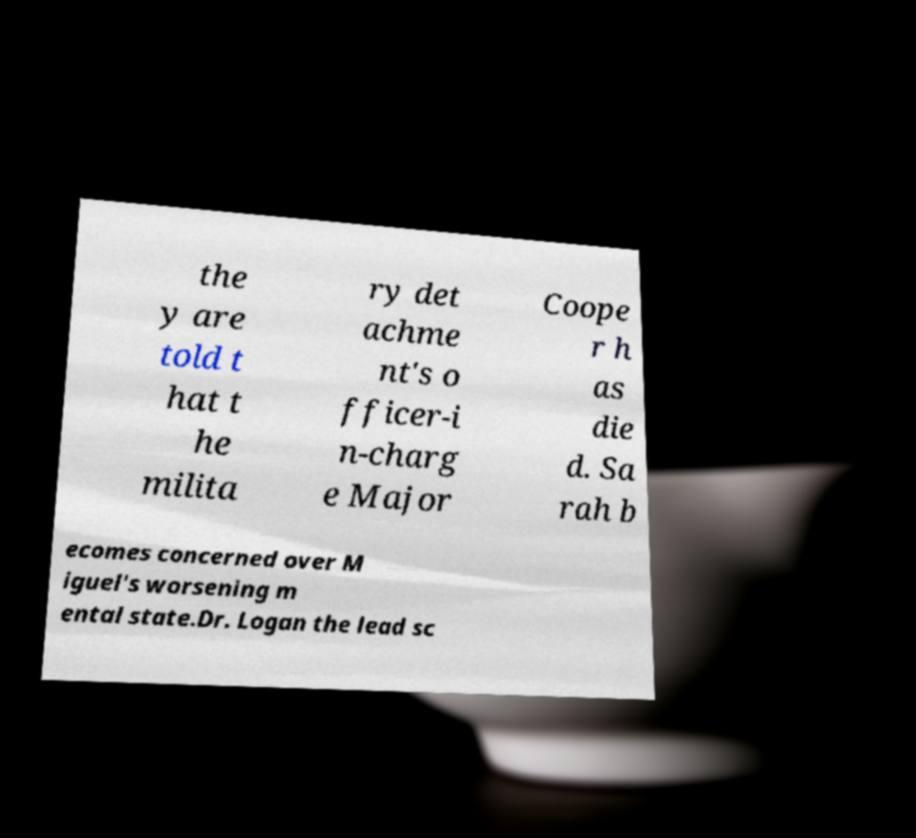For documentation purposes, I need the text within this image transcribed. Could you provide that? the y are told t hat t he milita ry det achme nt's o fficer-i n-charg e Major Coope r h as die d. Sa rah b ecomes concerned over M iguel's worsening m ental state.Dr. Logan the lead sc 